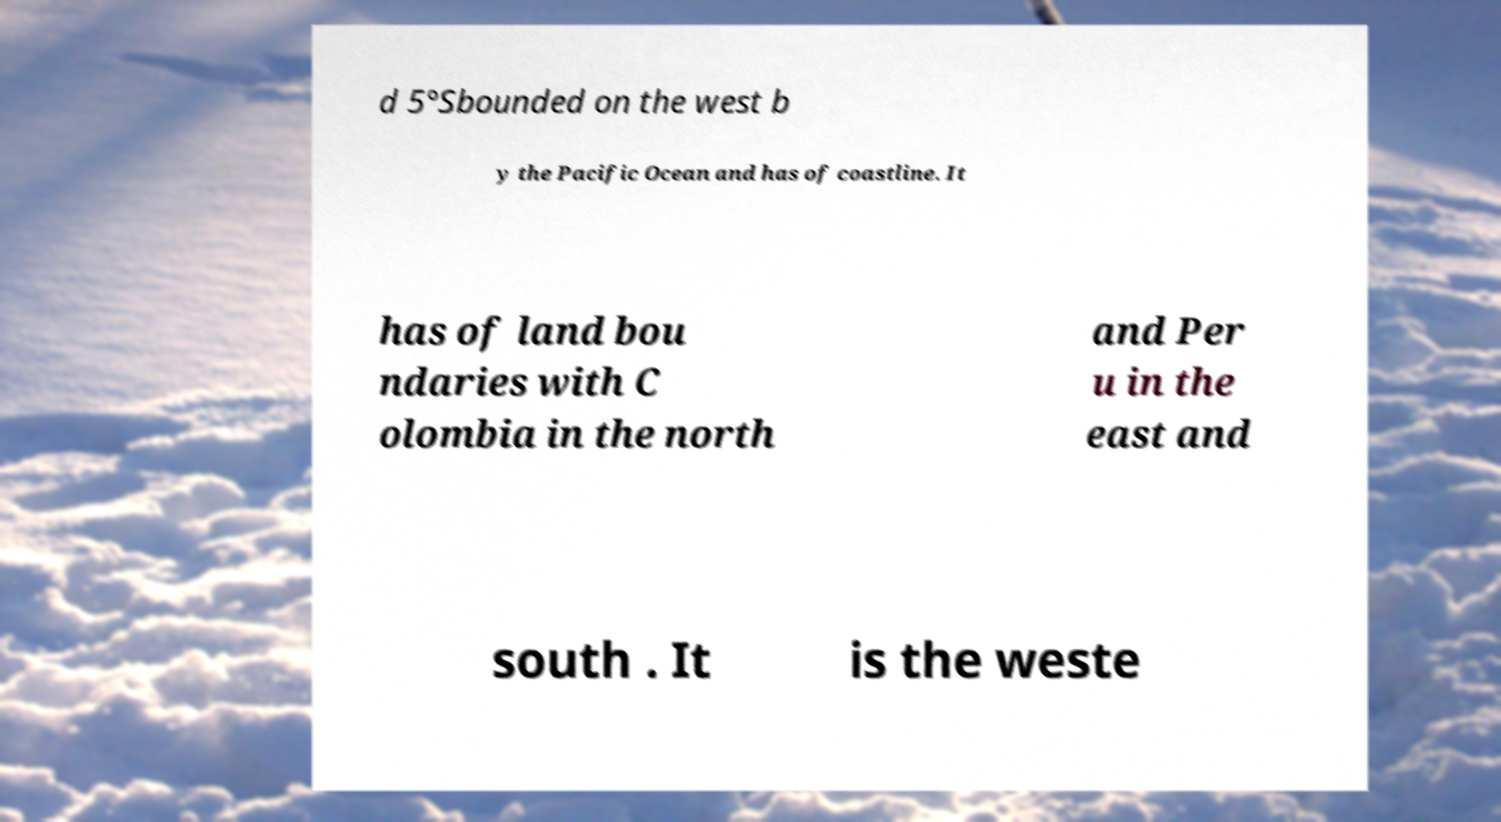Please identify and transcribe the text found in this image. d 5°Sbounded on the west b y the Pacific Ocean and has of coastline. It has of land bou ndaries with C olombia in the north and Per u in the east and south . It is the weste 